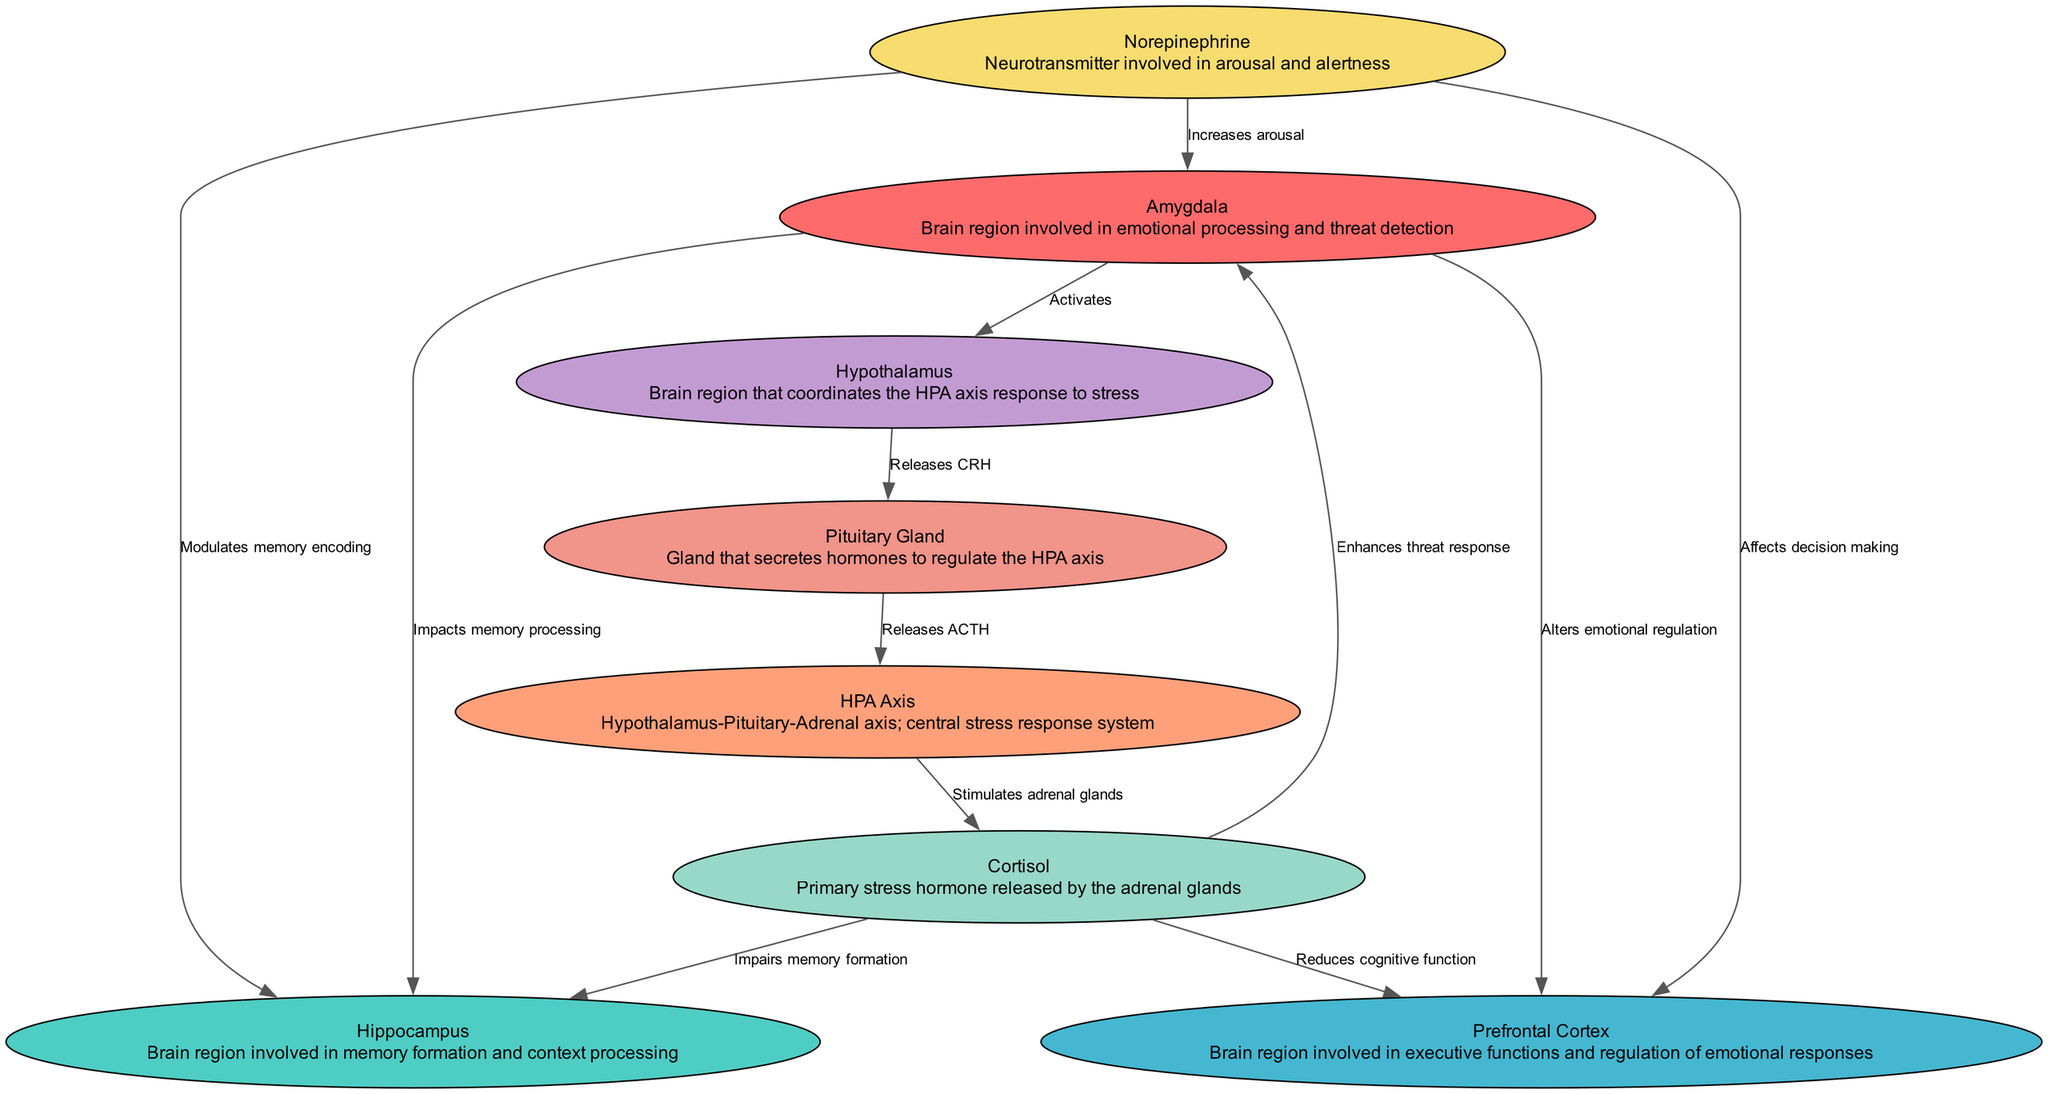What is the role of the amygdala? The amygdala is identified in the diagram as the brain region involved in emotional processing and threat detection. It is the node that directly impacts responses to perceived threats in the context of trauma.
Answer: Emotional processing and threat detection How many nodes are in the diagram? By counting each unique brain region and biochemical pathway depicted in the diagram, we find there are a total of eight nodes: amygdala, hippocampus, prefrontal cortex, HPA axis, cortisol, norepinephrine, hypothalamus, and pituitary gland.
Answer: Eight What hormone is released by the pituitary gland? The diagram indicates that the pituitary gland releases ACTH (Adrenocorticotropic hormone), which is a hormone that affects the HPA axis. This is displayed in the connection from the pituitary gland to the HPA axis in the edges of the diagram.
Answer: ACTH How does cortisol affect the hippocampus? The diagram indicates that cortisol, a hormone released during stress, impairs the memory formation capabilities of the hippocampus. This is shown by the direct edge connecting cortisol to the hippocampus with the label "Impairs memory formation."
Answer: Impairs memory formation Which two regions are influenced by norepinephrine? The diagram displays that norepinephrine has arrows pointing to three regions: the amygdala, hippocampus, and prefrontal cortex. However, the question specifically asks for the two regions influenced by norepinephrine; thus, we identify the first two as the amygdala and hippocampus.
Answer: Amygdala and hippocampus What is the effect of cortisol on the prefrontal cortex? According to the diagram, cortisol has a labeled edge pointing to the prefrontal cortex indicating it "Reduces cognitive function.” This highlights the detrimental impact cortisol can have on executive functions associated with this brain region during trauma responses.
Answer: Reduces cognitive function What initiates the HPA axis response? The diagram shows that the activation of the HPA axis begins with the amygdala, which activates the hypothalamus. This relationship indicates that the amygdala's detection of threats is critical in initiating this stress response pathway.
Answer: Amygdala What two functions are associated with the prefrontal cortex according to the diagram? The diagram outlines the prefrontal cortex's functions as being involved in the "regulation of emotional responses" and being subjected to effects from cortisol through the label that indicates it "Reduces cognitive function." These two roles characterize its importance in processing trauma.
Answer: Regulation of emotional responses and reduces cognitive function 